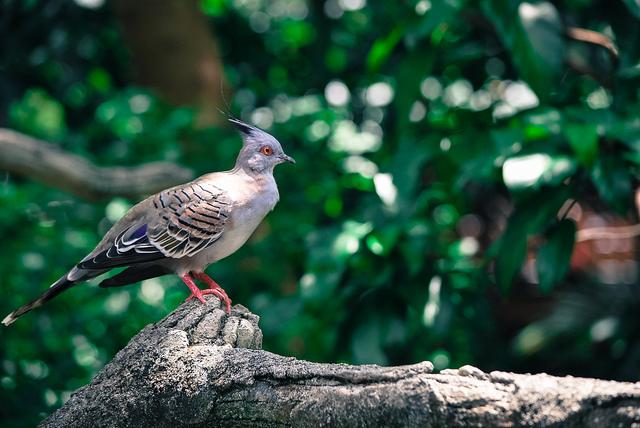What color are the leaves?
Quick response, please. Green. What type of bird is in the image?
Keep it brief. Pigeon. How many eyes do you see?
Write a very short answer. 1. What species is this?
Concise answer only. Bird. 